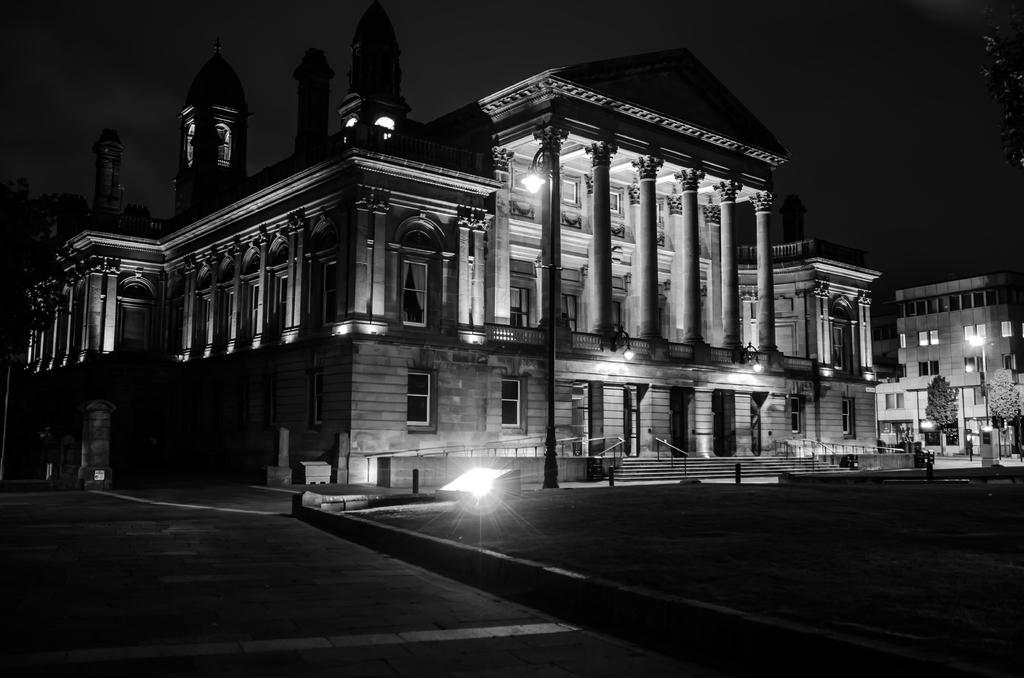What type of structures can be seen in the image? There are buildings in the image. What else can be seen in the image besides buildings? There are poles, trees, and lights in the image. Can you see the queen walking among the trees in the image? There is no queen or any indication of a person walking in the image; it only features buildings, poles, trees, and lights. 